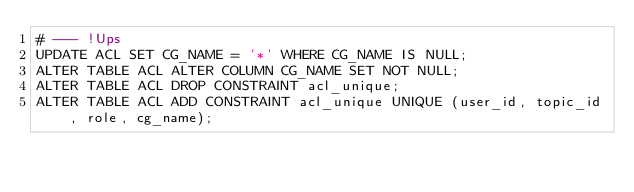<code> <loc_0><loc_0><loc_500><loc_500><_SQL_># --- !Ups
UPDATE ACL SET CG_NAME = '*' WHERE CG_NAME IS NULL;
ALTER TABLE ACL ALTER COLUMN CG_NAME SET NOT NULL;
ALTER TABLE ACL DROP CONSTRAINT acl_unique;
ALTER TABLE ACL ADD CONSTRAINT acl_unique UNIQUE (user_id, topic_id, role, cg_name);</code> 